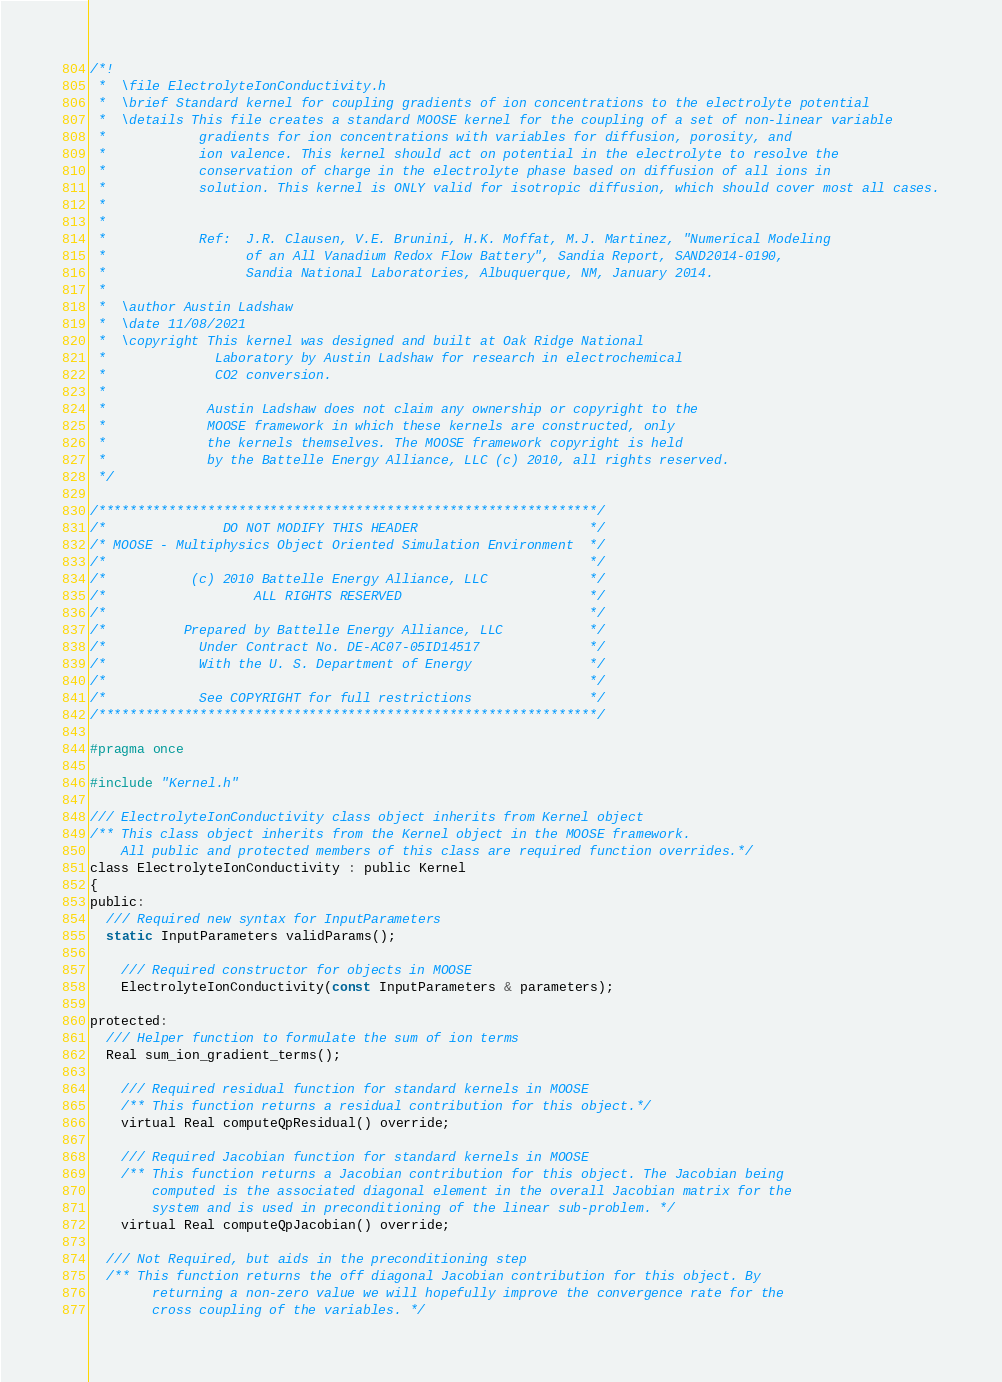<code> <loc_0><loc_0><loc_500><loc_500><_C_>/*!
 *  \file ElectrolyteIonConductivity.h
 *	\brief Standard kernel for coupling gradients of ion concentrations to the electrolyte potential
 *	\details This file creates a standard MOOSE kernel for the coupling of a set of non-linear variable
 *            gradients for ion concentrations with variables for diffusion, porosity, and
 *            ion valence. This kernel should act on potential in the electrolyte to resolve the
 *            conservation of charge in the electrolyte phase based on diffusion of all ions in
 *            solution. This kernel is ONLY valid for isotropic diffusion, which should cover most all cases.
 *
 *
 *            Ref:  J.R. Clausen, V.E. Brunini, H.K. Moffat, M.J. Martinez, "Numerical Modeling
 *                  of an All Vanadium Redox Flow Battery", Sandia Report, SAND2014-0190,
 *                  Sandia National Laboratories, Albuquerque, NM, January 2014.
 *
 *  \author Austin Ladshaw
 *	\date 11/08/2021
 *	\copyright This kernel was designed and built at Oak Ridge National
 *              Laboratory by Austin Ladshaw for research in electrochemical
 *              CO2 conversion.
 *
 *			   Austin Ladshaw does not claim any ownership or copyright to the
 *			   MOOSE framework in which these kernels are constructed, only
 *			   the kernels themselves. The MOOSE framework copyright is held
 *			   by the Battelle Energy Alliance, LLC (c) 2010, all rights reserved.
 */

/****************************************************************/
/*               DO NOT MODIFY THIS HEADER                      */
/* MOOSE - Multiphysics Object Oriented Simulation Environment  */
/*                                                              */
/*           (c) 2010 Battelle Energy Alliance, LLC             */
/*                   ALL RIGHTS RESERVED                        */
/*                                                              */
/*          Prepared by Battelle Energy Alliance, LLC           */
/*            Under Contract No. DE-AC07-05ID14517              */
/*            With the U. S. Department of Energy               */
/*                                                              */
/*            See COPYRIGHT for full restrictions               */
/****************************************************************/

#pragma once

#include "Kernel.h"

/// ElectrolyteIonConductivity class object inherits from Kernel object
/** This class object inherits from the Kernel object in the MOOSE framework.
	All public and protected members of this class are required function overrides.*/
class ElectrolyteIonConductivity : public Kernel
{
public:
  /// Required new syntax for InputParameters
  static InputParameters validParams();

	/// Required constructor for objects in MOOSE
	ElectrolyteIonConductivity(const InputParameters & parameters);

protected:
  /// Helper function to formulate the sum of ion terms
  Real sum_ion_gradient_terms();

	/// Required residual function for standard kernels in MOOSE
	/** This function returns a residual contribution for this object.*/
	virtual Real computeQpResidual() override;

	/// Required Jacobian function for standard kernels in MOOSE
	/** This function returns a Jacobian contribution for this object. The Jacobian being
		computed is the associated diagonal element in the overall Jacobian matrix for the
		system and is used in preconditioning of the linear sub-problem. */
	virtual Real computeQpJacobian() override;

  /// Not Required, but aids in the preconditioning step
  /** This function returns the off diagonal Jacobian contribution for this object. By
        returning a non-zero value we will hopefully improve the convergence rate for the
        cross coupling of the variables. */</code> 